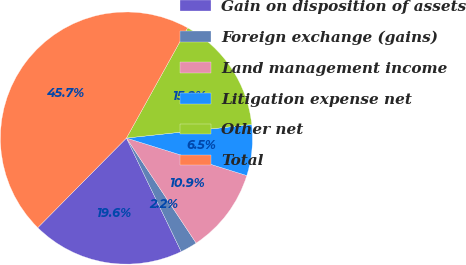Convert chart. <chart><loc_0><loc_0><loc_500><loc_500><pie_chart><fcel>Gain on disposition of assets<fcel>Foreign exchange (gains)<fcel>Land management income<fcel>Litigation expense net<fcel>Other net<fcel>Total<nl><fcel>19.57%<fcel>2.17%<fcel>10.87%<fcel>6.52%<fcel>15.22%<fcel>45.65%<nl></chart> 